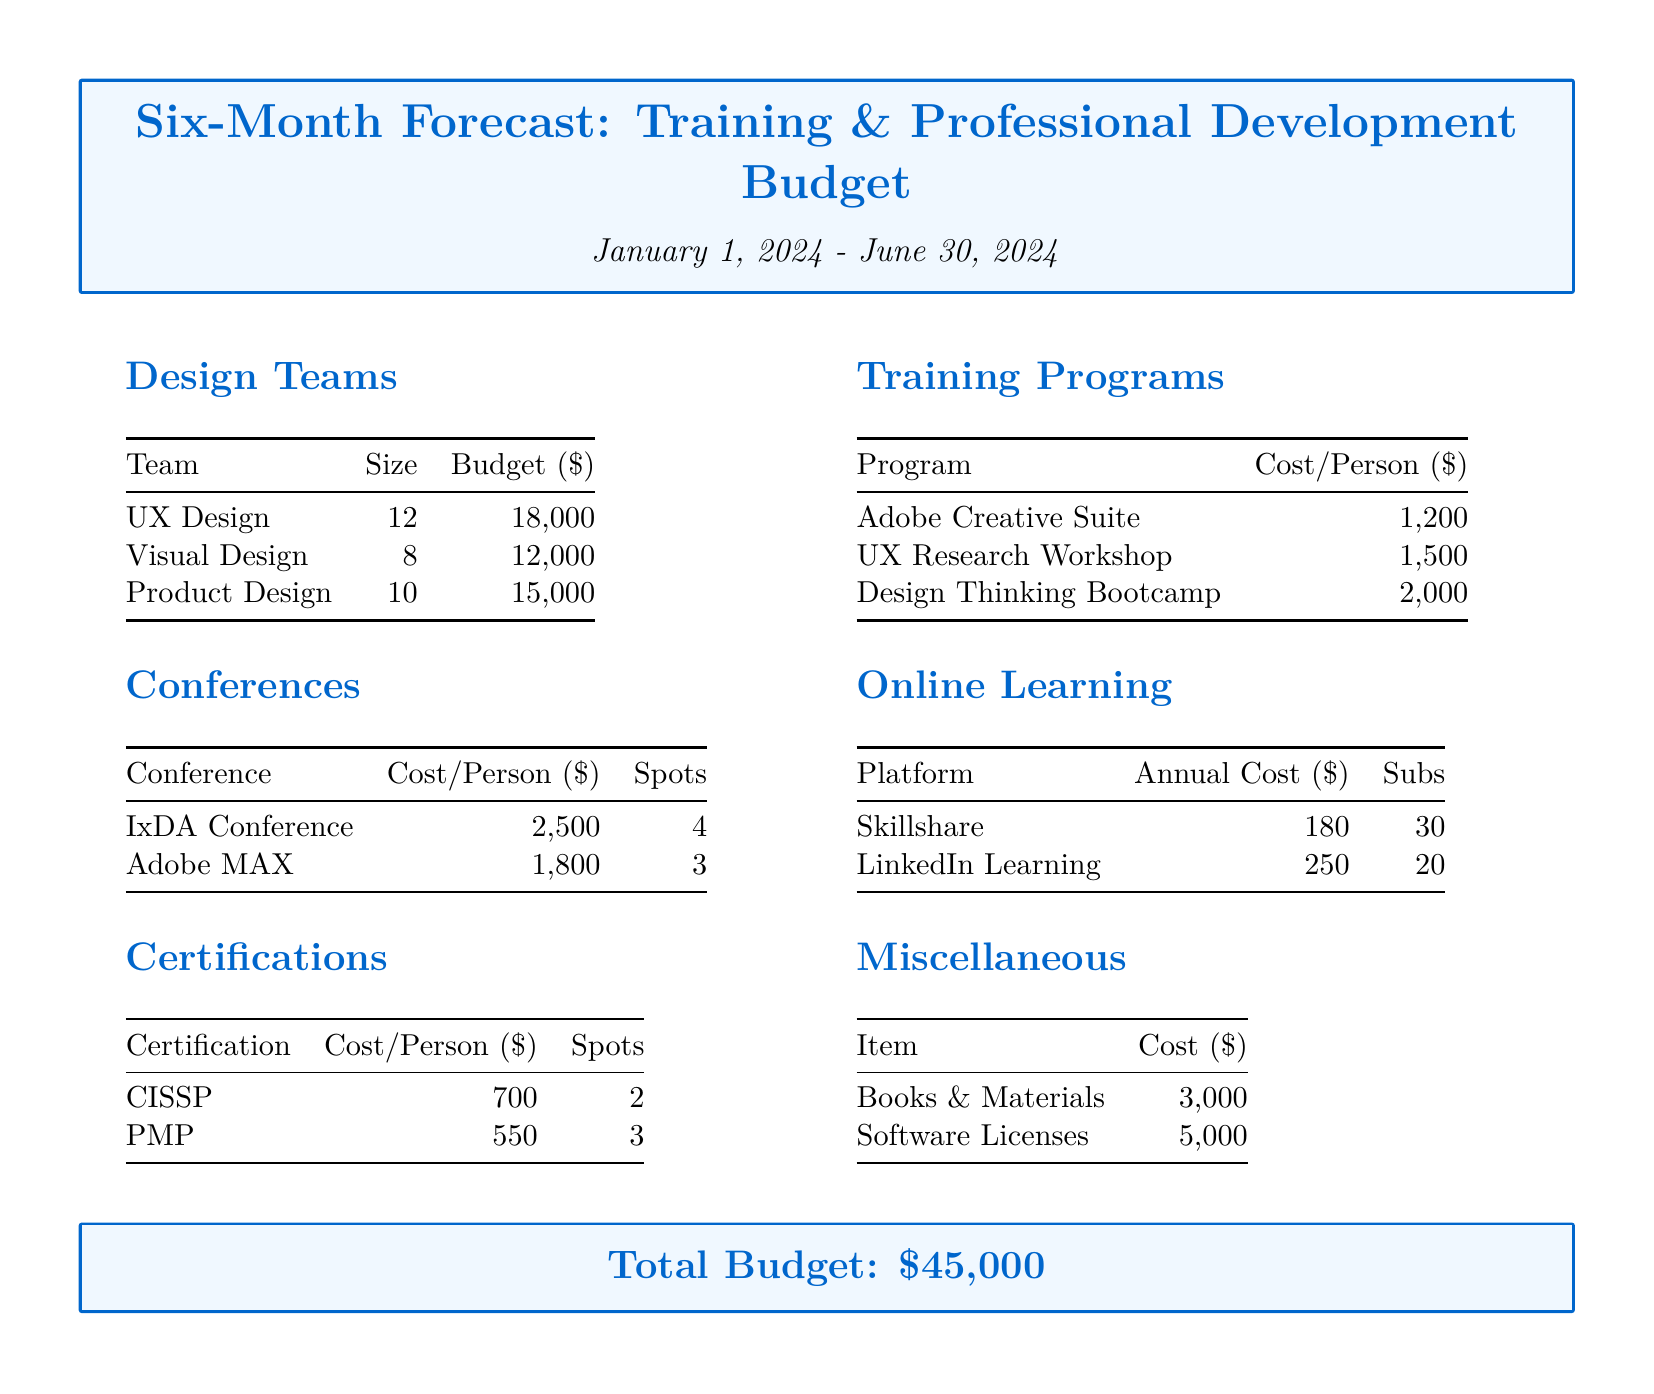What is the total budget? The total budget is stated at the end of the document, summarizing all expenses across design teams, training, conferences, online learning, certifications, and miscellaneous items.
Answer: $45,000 How many team members are in the UX Design team? The size of each design team is listed in the "Design Teams" section, with specific counts for each team.
Answer: 12 What is the cost per person for the Adobe Creative Suite training program? This cost is detailed within the "Training Programs" section of the document, providing specific training costs for each program.
Answer: $1,200 How many spots are available for the IxDA Conference? The number of spots for each conference is given in the "Conferences" section, under the respective conference costs.
Answer: 4 What is the annual cost of Skillshare? The annual costs for various online learning platforms are provided in the "Online Learning" section.
Answer: $180 How many spots are available for the PMP certification? This information is found in the "Certifications" section, which specifies the number of spots available for each certification.
Answer: 3 What are the miscellaneous expenses listed? The miscellaneous expenses detail the specific costs of items mentioned in the "Miscellaneous" section of the document.
Answer: Books & Materials, Software Licenses How much is allocated for the Product Design team? The budget allocated to each design team is outlined in the “Design Teams” section, which lists the budget for each team individually.
Answer: $15,000 What is the cost for the UX Research Workshop per person? The cost per person for each training program is specified in the "Training Programs" section.
Answer: $1,500 